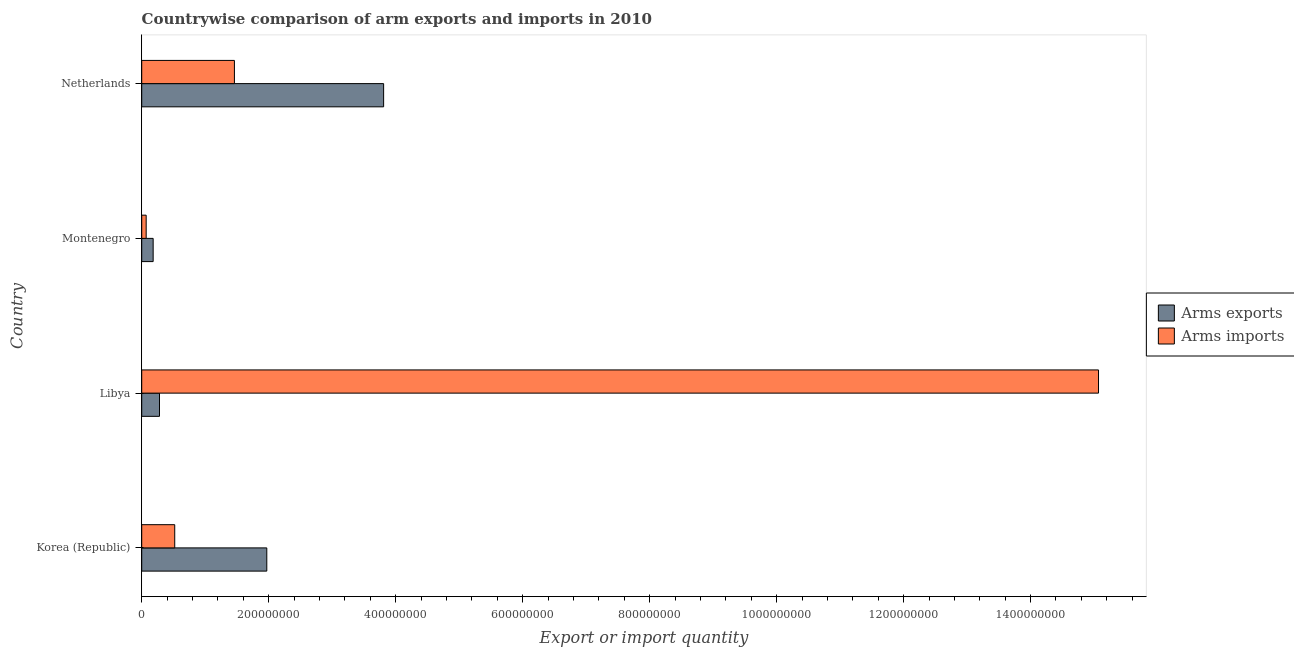How many different coloured bars are there?
Keep it short and to the point. 2. How many groups of bars are there?
Your answer should be very brief. 4. Are the number of bars on each tick of the Y-axis equal?
Provide a succinct answer. Yes. How many bars are there on the 4th tick from the top?
Your answer should be compact. 2. How many bars are there on the 1st tick from the bottom?
Your answer should be very brief. 2. What is the label of the 3rd group of bars from the top?
Offer a very short reply. Libya. What is the arms exports in Montenegro?
Give a very brief answer. 1.80e+07. Across all countries, what is the maximum arms exports?
Provide a succinct answer. 3.81e+08. Across all countries, what is the minimum arms exports?
Give a very brief answer. 1.80e+07. In which country was the arms imports maximum?
Keep it short and to the point. Libya. In which country was the arms exports minimum?
Provide a succinct answer. Montenegro. What is the total arms imports in the graph?
Your answer should be very brief. 1.71e+09. What is the difference between the arms imports in Korea (Republic) and that in Netherlands?
Make the answer very short. -9.40e+07. What is the difference between the arms imports in Netherlands and the arms exports in Korea (Republic)?
Your answer should be very brief. -5.10e+07. What is the average arms exports per country?
Your response must be concise. 1.56e+08. What is the difference between the arms imports and arms exports in Libya?
Ensure brevity in your answer.  1.48e+09. What is the ratio of the arms imports in Korea (Republic) to that in Netherlands?
Give a very brief answer. 0.36. Is the arms imports in Korea (Republic) less than that in Montenegro?
Make the answer very short. No. What is the difference between the highest and the second highest arms exports?
Provide a short and direct response. 1.84e+08. What is the difference between the highest and the lowest arms exports?
Ensure brevity in your answer.  3.63e+08. In how many countries, is the arms exports greater than the average arms exports taken over all countries?
Your response must be concise. 2. Is the sum of the arms imports in Korea (Republic) and Libya greater than the maximum arms exports across all countries?
Keep it short and to the point. Yes. What does the 1st bar from the top in Montenegro represents?
Give a very brief answer. Arms imports. What does the 2nd bar from the bottom in Montenegro represents?
Your answer should be compact. Arms imports. Are all the bars in the graph horizontal?
Keep it short and to the point. Yes. Does the graph contain any zero values?
Provide a short and direct response. No. How are the legend labels stacked?
Keep it short and to the point. Vertical. What is the title of the graph?
Offer a terse response. Countrywise comparison of arm exports and imports in 2010. Does "Register a business" appear as one of the legend labels in the graph?
Give a very brief answer. No. What is the label or title of the X-axis?
Offer a very short reply. Export or import quantity. What is the label or title of the Y-axis?
Your answer should be very brief. Country. What is the Export or import quantity of Arms exports in Korea (Republic)?
Offer a very short reply. 1.97e+08. What is the Export or import quantity in Arms imports in Korea (Republic)?
Offer a terse response. 5.20e+07. What is the Export or import quantity of Arms exports in Libya?
Give a very brief answer. 2.80e+07. What is the Export or import quantity in Arms imports in Libya?
Provide a succinct answer. 1.51e+09. What is the Export or import quantity in Arms exports in Montenegro?
Offer a terse response. 1.80e+07. What is the Export or import quantity in Arms exports in Netherlands?
Make the answer very short. 3.81e+08. What is the Export or import quantity in Arms imports in Netherlands?
Offer a very short reply. 1.46e+08. Across all countries, what is the maximum Export or import quantity of Arms exports?
Keep it short and to the point. 3.81e+08. Across all countries, what is the maximum Export or import quantity of Arms imports?
Give a very brief answer. 1.51e+09. Across all countries, what is the minimum Export or import quantity of Arms exports?
Provide a succinct answer. 1.80e+07. What is the total Export or import quantity of Arms exports in the graph?
Your response must be concise. 6.24e+08. What is the total Export or import quantity in Arms imports in the graph?
Your answer should be very brief. 1.71e+09. What is the difference between the Export or import quantity in Arms exports in Korea (Republic) and that in Libya?
Your answer should be very brief. 1.69e+08. What is the difference between the Export or import quantity of Arms imports in Korea (Republic) and that in Libya?
Give a very brief answer. -1.46e+09. What is the difference between the Export or import quantity of Arms exports in Korea (Republic) and that in Montenegro?
Ensure brevity in your answer.  1.79e+08. What is the difference between the Export or import quantity in Arms imports in Korea (Republic) and that in Montenegro?
Give a very brief answer. 4.50e+07. What is the difference between the Export or import quantity of Arms exports in Korea (Republic) and that in Netherlands?
Provide a short and direct response. -1.84e+08. What is the difference between the Export or import quantity in Arms imports in Korea (Republic) and that in Netherlands?
Your answer should be compact. -9.40e+07. What is the difference between the Export or import quantity in Arms exports in Libya and that in Montenegro?
Provide a succinct answer. 1.00e+07. What is the difference between the Export or import quantity in Arms imports in Libya and that in Montenegro?
Offer a very short reply. 1.50e+09. What is the difference between the Export or import quantity of Arms exports in Libya and that in Netherlands?
Ensure brevity in your answer.  -3.53e+08. What is the difference between the Export or import quantity in Arms imports in Libya and that in Netherlands?
Your answer should be compact. 1.36e+09. What is the difference between the Export or import quantity in Arms exports in Montenegro and that in Netherlands?
Give a very brief answer. -3.63e+08. What is the difference between the Export or import quantity in Arms imports in Montenegro and that in Netherlands?
Offer a terse response. -1.39e+08. What is the difference between the Export or import quantity of Arms exports in Korea (Republic) and the Export or import quantity of Arms imports in Libya?
Your answer should be very brief. -1.31e+09. What is the difference between the Export or import quantity of Arms exports in Korea (Republic) and the Export or import quantity of Arms imports in Montenegro?
Provide a short and direct response. 1.90e+08. What is the difference between the Export or import quantity in Arms exports in Korea (Republic) and the Export or import quantity in Arms imports in Netherlands?
Your answer should be compact. 5.10e+07. What is the difference between the Export or import quantity of Arms exports in Libya and the Export or import quantity of Arms imports in Montenegro?
Offer a very short reply. 2.10e+07. What is the difference between the Export or import quantity in Arms exports in Libya and the Export or import quantity in Arms imports in Netherlands?
Offer a very short reply. -1.18e+08. What is the difference between the Export or import quantity in Arms exports in Montenegro and the Export or import quantity in Arms imports in Netherlands?
Ensure brevity in your answer.  -1.28e+08. What is the average Export or import quantity of Arms exports per country?
Provide a short and direct response. 1.56e+08. What is the average Export or import quantity of Arms imports per country?
Offer a terse response. 4.28e+08. What is the difference between the Export or import quantity of Arms exports and Export or import quantity of Arms imports in Korea (Republic)?
Make the answer very short. 1.45e+08. What is the difference between the Export or import quantity of Arms exports and Export or import quantity of Arms imports in Libya?
Your answer should be compact. -1.48e+09. What is the difference between the Export or import quantity of Arms exports and Export or import quantity of Arms imports in Montenegro?
Make the answer very short. 1.10e+07. What is the difference between the Export or import quantity of Arms exports and Export or import quantity of Arms imports in Netherlands?
Your answer should be compact. 2.35e+08. What is the ratio of the Export or import quantity of Arms exports in Korea (Republic) to that in Libya?
Keep it short and to the point. 7.04. What is the ratio of the Export or import quantity of Arms imports in Korea (Republic) to that in Libya?
Your response must be concise. 0.03. What is the ratio of the Export or import quantity in Arms exports in Korea (Republic) to that in Montenegro?
Your answer should be very brief. 10.94. What is the ratio of the Export or import quantity of Arms imports in Korea (Republic) to that in Montenegro?
Your answer should be very brief. 7.43. What is the ratio of the Export or import quantity of Arms exports in Korea (Republic) to that in Netherlands?
Keep it short and to the point. 0.52. What is the ratio of the Export or import quantity of Arms imports in Korea (Republic) to that in Netherlands?
Offer a terse response. 0.36. What is the ratio of the Export or import quantity in Arms exports in Libya to that in Montenegro?
Provide a short and direct response. 1.56. What is the ratio of the Export or import quantity of Arms imports in Libya to that in Montenegro?
Your answer should be compact. 215.29. What is the ratio of the Export or import quantity of Arms exports in Libya to that in Netherlands?
Offer a terse response. 0.07. What is the ratio of the Export or import quantity in Arms imports in Libya to that in Netherlands?
Keep it short and to the point. 10.32. What is the ratio of the Export or import quantity of Arms exports in Montenegro to that in Netherlands?
Your answer should be compact. 0.05. What is the ratio of the Export or import quantity of Arms imports in Montenegro to that in Netherlands?
Make the answer very short. 0.05. What is the difference between the highest and the second highest Export or import quantity of Arms exports?
Provide a short and direct response. 1.84e+08. What is the difference between the highest and the second highest Export or import quantity in Arms imports?
Give a very brief answer. 1.36e+09. What is the difference between the highest and the lowest Export or import quantity in Arms exports?
Ensure brevity in your answer.  3.63e+08. What is the difference between the highest and the lowest Export or import quantity of Arms imports?
Give a very brief answer. 1.50e+09. 